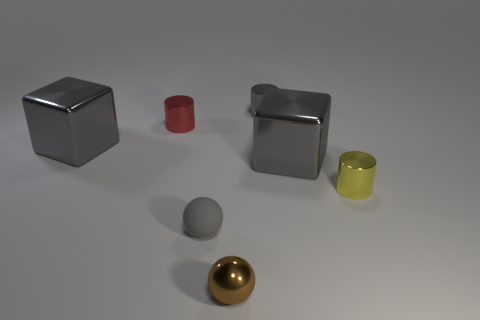Subtract all gray shiny cylinders. How many cylinders are left? 2 Subtract all cylinders. How many objects are left? 4 Subtract 1 cylinders. How many cylinders are left? 2 Add 2 small brown spheres. How many objects exist? 9 Subtract all red cylinders. How many cylinders are left? 2 Subtract all brown things. Subtract all large cyan metal cubes. How many objects are left? 6 Add 2 large metallic cubes. How many large metallic cubes are left? 4 Add 1 red shiny cylinders. How many red shiny cylinders exist? 2 Subtract 2 gray blocks. How many objects are left? 5 Subtract all cyan cylinders. Subtract all purple spheres. How many cylinders are left? 3 